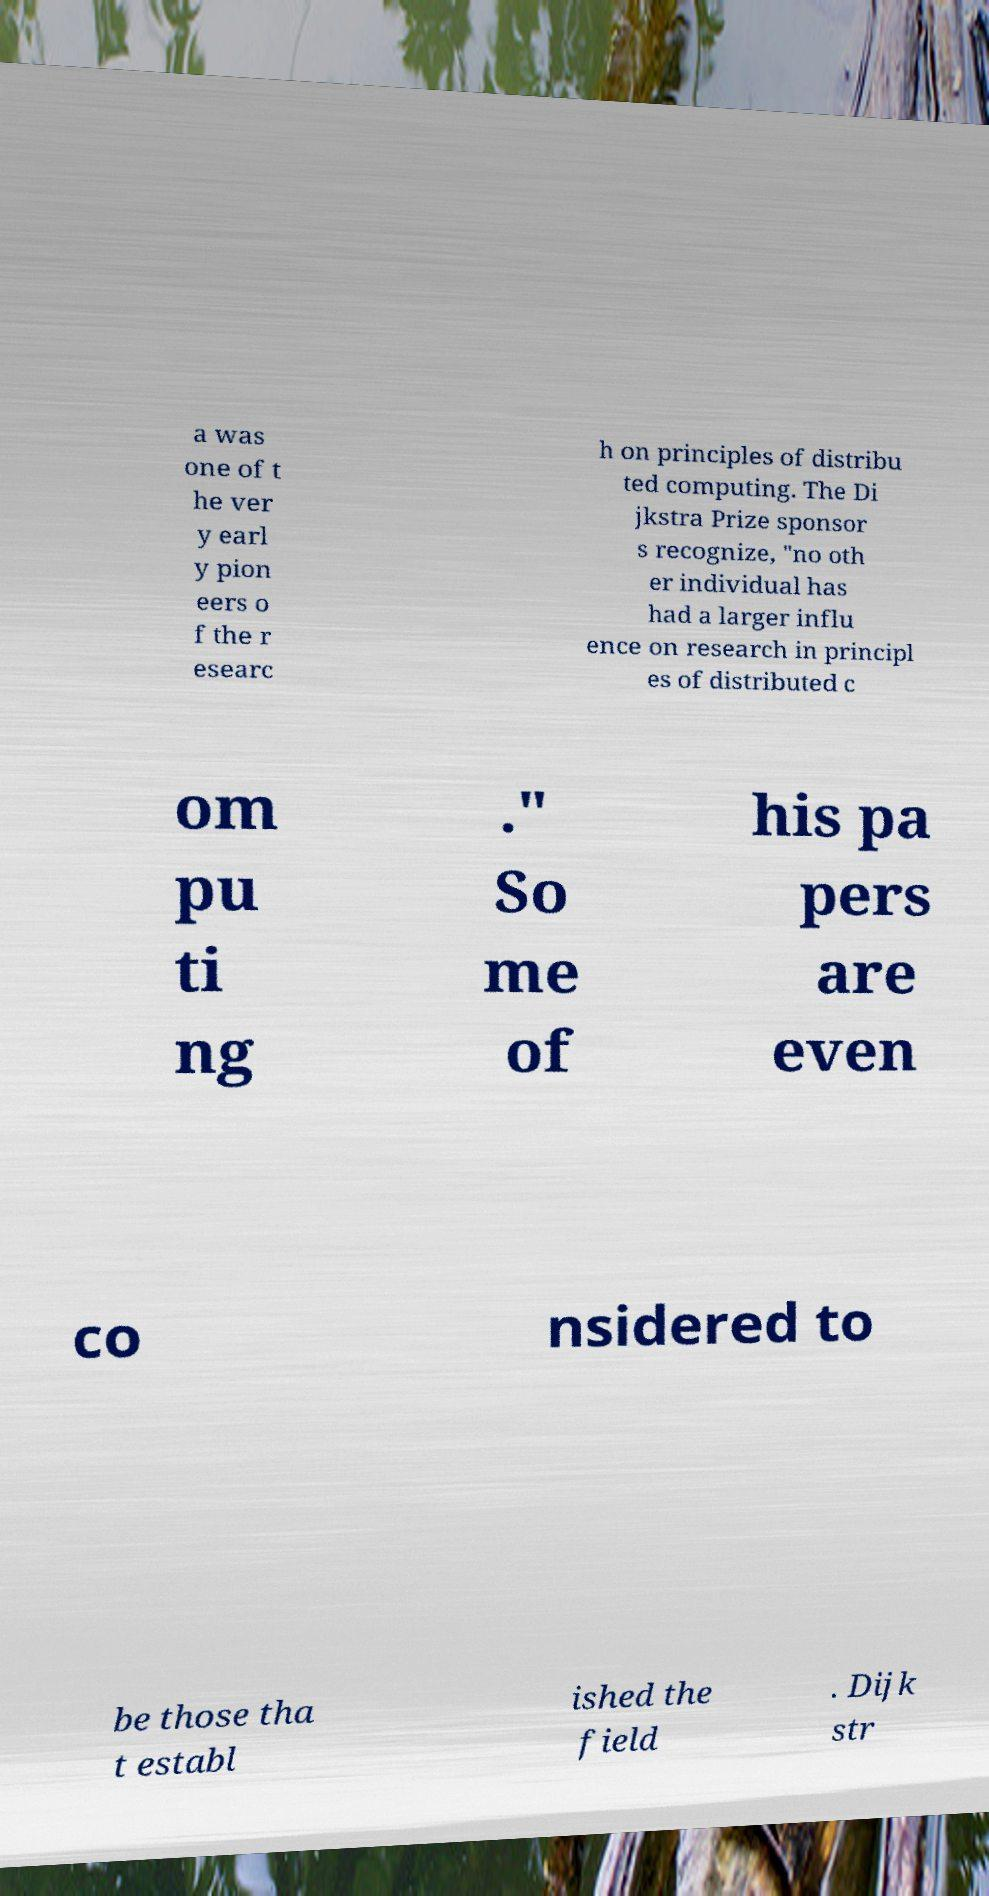Please identify and transcribe the text found in this image. a was one of t he ver y earl y pion eers o f the r esearc h on principles of distribu ted computing. The Di jkstra Prize sponsor s recognize, "no oth er individual has had a larger influ ence on research in principl es of distributed c om pu ti ng ." So me of his pa pers are even co nsidered to be those tha t establ ished the field . Dijk str 